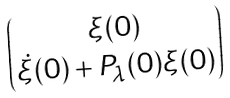<formula> <loc_0><loc_0><loc_500><loc_500>\begin{pmatrix} \xi ( 0 ) \\ \dot { \xi } ( 0 ) + P _ { \lambda } ( 0 ) \xi ( 0 ) \end{pmatrix}</formula> 